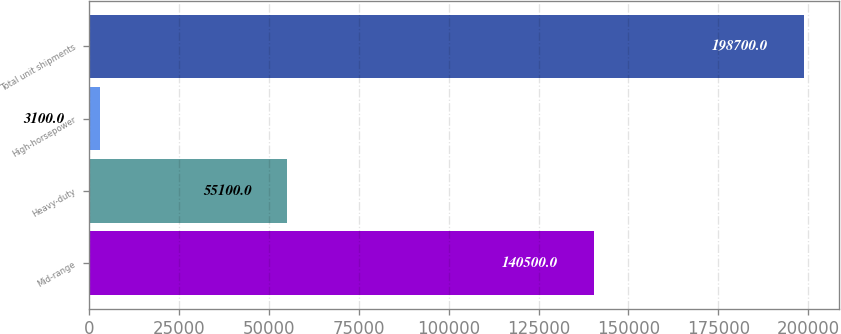Convert chart to OTSL. <chart><loc_0><loc_0><loc_500><loc_500><bar_chart><fcel>Mid-range<fcel>Heavy-duty<fcel>High-horsepower<fcel>Total unit shipments<nl><fcel>140500<fcel>55100<fcel>3100<fcel>198700<nl></chart> 